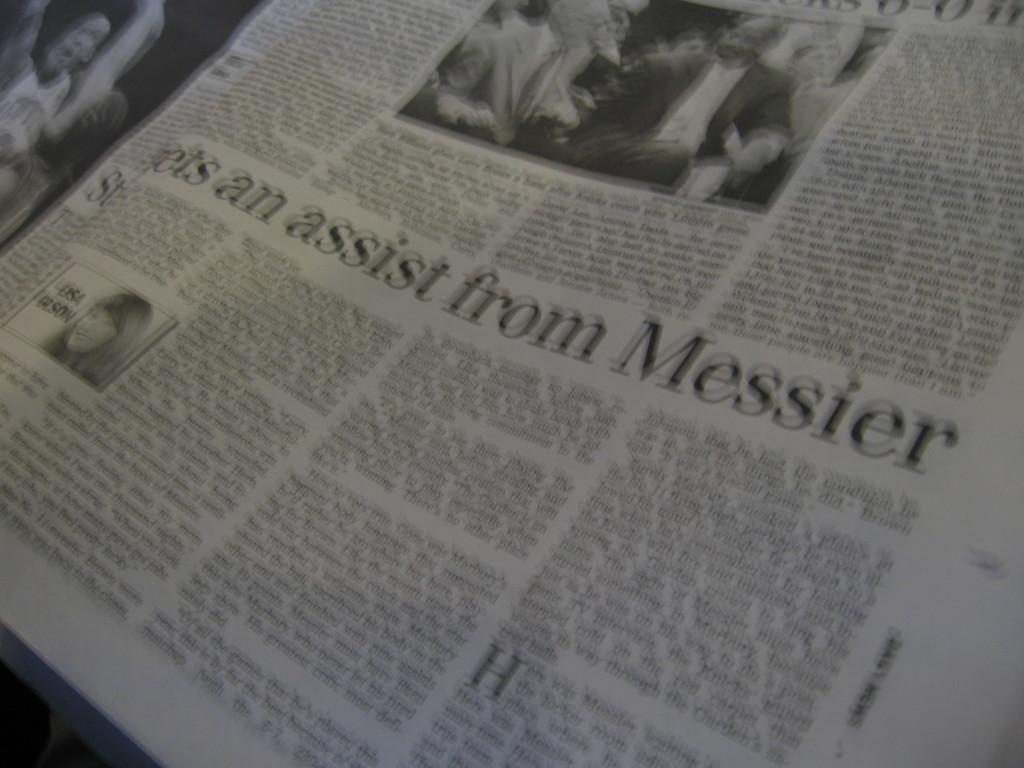Describe this image in one or two sentences. Here in this picture we can see a newspaper present and we can see some photos and text on it over there. 